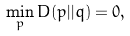<formula> <loc_0><loc_0><loc_500><loc_500>\min _ { p } D ( p | | q ) = 0 ,</formula> 